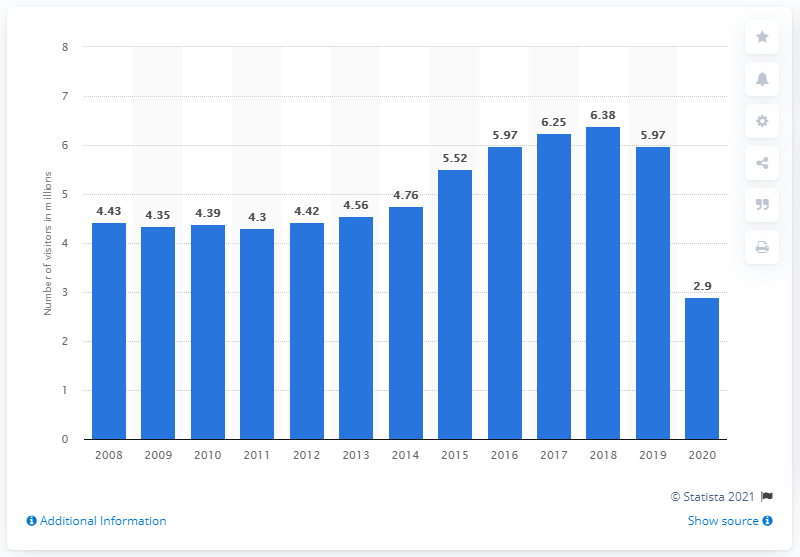Mention a couple of crucial points in this snapshot. In 2019, the Grand Canyon National Park received a total of 5,970,397 recreational visitors. In 2020, the Grand Canyon National Park received a total of 2,962,706 recreational visitors. 